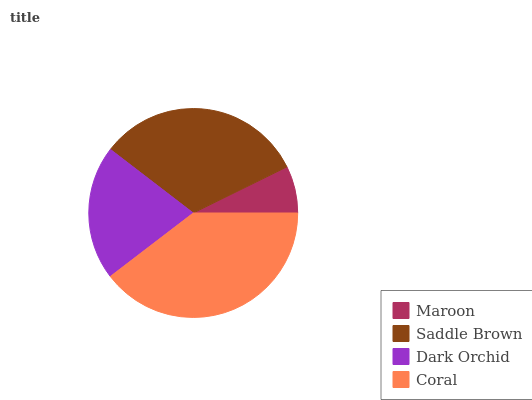Is Maroon the minimum?
Answer yes or no. Yes. Is Coral the maximum?
Answer yes or no. Yes. Is Saddle Brown the minimum?
Answer yes or no. No. Is Saddle Brown the maximum?
Answer yes or no. No. Is Saddle Brown greater than Maroon?
Answer yes or no. Yes. Is Maroon less than Saddle Brown?
Answer yes or no. Yes. Is Maroon greater than Saddle Brown?
Answer yes or no. No. Is Saddle Brown less than Maroon?
Answer yes or no. No. Is Saddle Brown the high median?
Answer yes or no. Yes. Is Dark Orchid the low median?
Answer yes or no. Yes. Is Coral the high median?
Answer yes or no. No. Is Coral the low median?
Answer yes or no. No. 